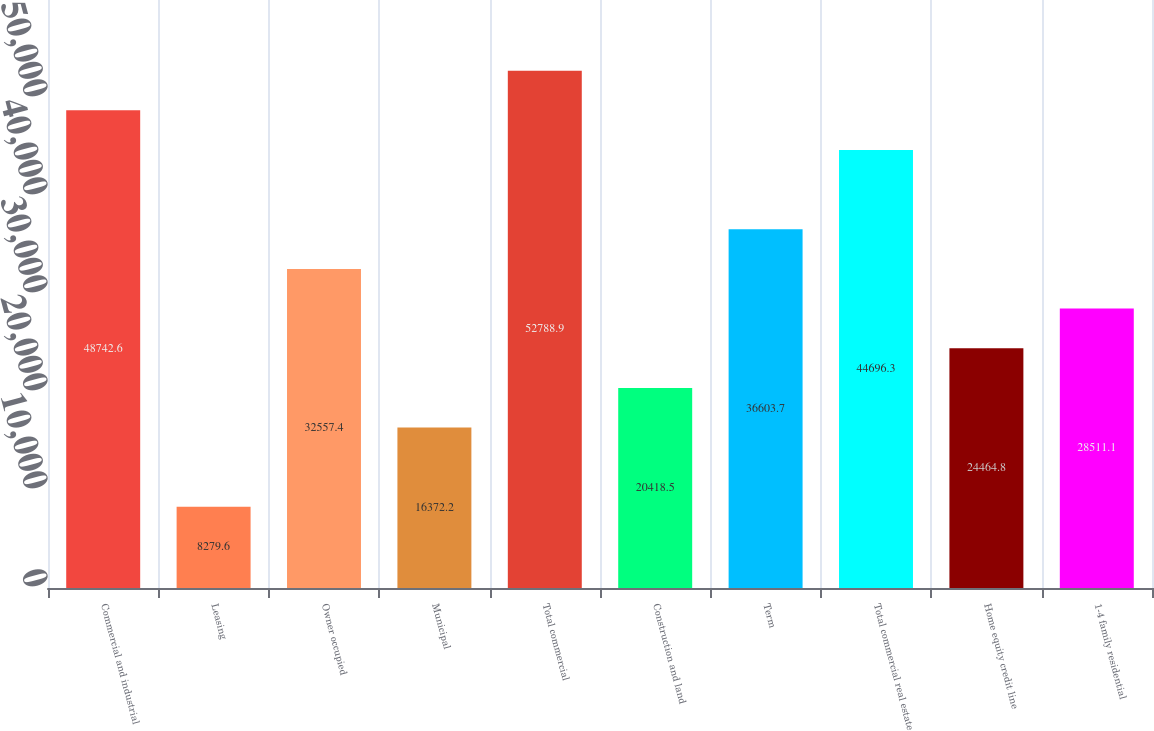Convert chart. <chart><loc_0><loc_0><loc_500><loc_500><bar_chart><fcel>Commercial and industrial<fcel>Leasing<fcel>Owner occupied<fcel>Municipal<fcel>Total commercial<fcel>Construction and land<fcel>Term<fcel>Total commercial real estate<fcel>Home equity credit line<fcel>1-4 family residential<nl><fcel>48742.6<fcel>8279.6<fcel>32557.4<fcel>16372.2<fcel>52788.9<fcel>20418.5<fcel>36603.7<fcel>44696.3<fcel>24464.8<fcel>28511.1<nl></chart> 